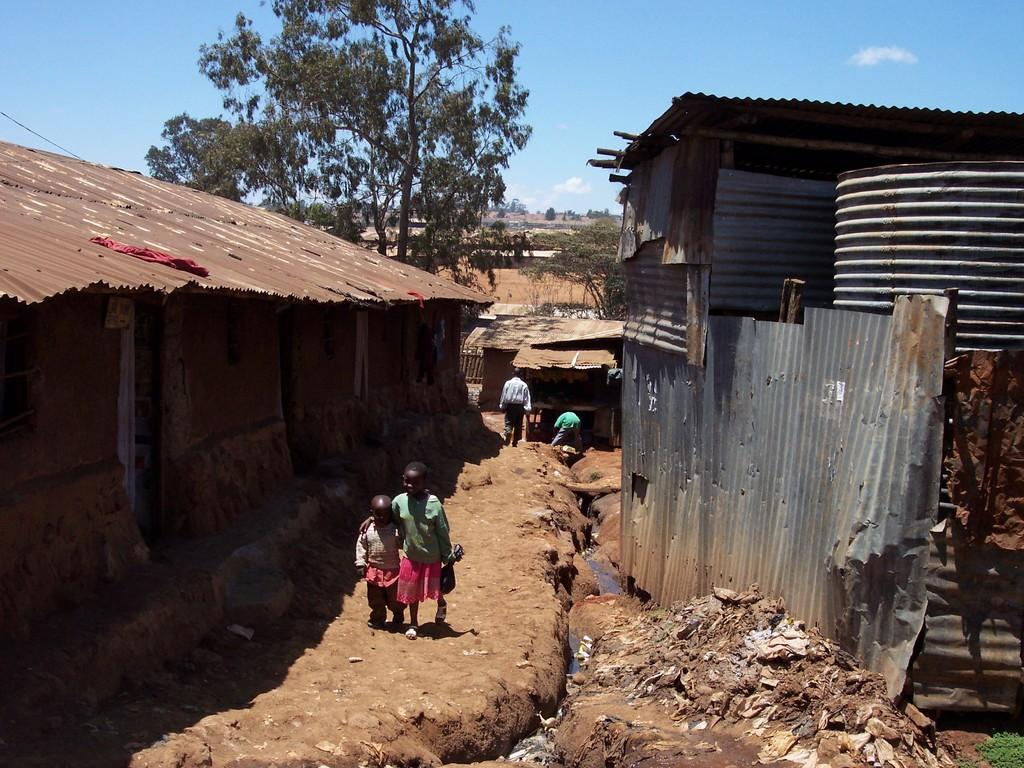What are the main subjects in the image? There are two children walking in the image. What structures are present on either side of the children? There are iron sheds on either side of the children. What type of vegetation can be seen in the background of the image? There are trees visible at the back side of the image. How would you describe the weather in the image? The sky is cloudy in the image. What type of connection can be seen between the two children in the image? There is no visible connection between the two children in the image. How many bushes are present in the image? There are no bushes mentioned or visible in the image. 